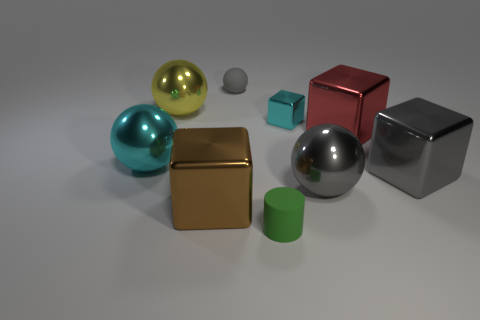There is a cyan thing to the left of the tiny thing that is to the right of the tiny matte object that is in front of the tiny gray object; what is its material?
Your answer should be compact. Metal. There is a big metallic thing that is in front of the large sphere that is on the right side of the large brown metallic block; what color is it?
Provide a short and direct response. Brown. There is a matte cylinder that is the same size as the cyan block; what is its color?
Offer a terse response. Green. What number of big objects are either yellow matte balls or gray matte objects?
Provide a short and direct response. 0. Are there more big metallic balls that are to the right of the big cyan metallic object than large red cubes on the left side of the rubber sphere?
Provide a short and direct response. Yes. What size is the metal sphere that is the same color as the small metallic object?
Ensure brevity in your answer.  Large. How many other things are the same size as the cyan ball?
Provide a succinct answer. 5. Is the large cube left of the tiny gray object made of the same material as the cylinder?
Give a very brief answer. No. How many other objects are there of the same color as the cylinder?
Provide a succinct answer. 0. What number of other objects are there of the same shape as the green matte thing?
Provide a succinct answer. 0. 